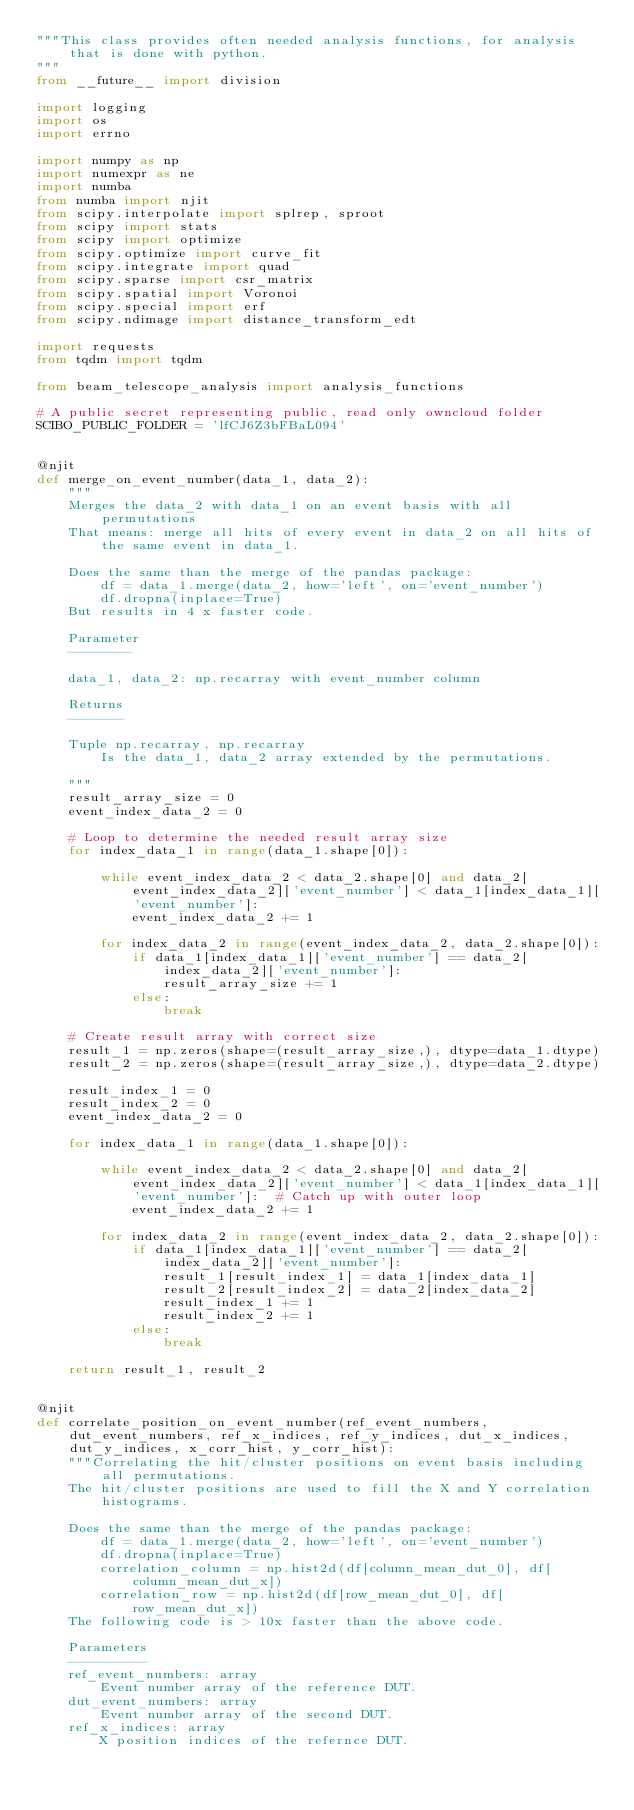<code> <loc_0><loc_0><loc_500><loc_500><_Python_>"""This class provides often needed analysis functions, for analysis that is done with python.
"""
from __future__ import division

import logging
import os
import errno

import numpy as np
import numexpr as ne
import numba
from numba import njit
from scipy.interpolate import splrep, sproot
from scipy import stats
from scipy import optimize
from scipy.optimize import curve_fit
from scipy.integrate import quad
from scipy.sparse import csr_matrix
from scipy.spatial import Voronoi
from scipy.special import erf
from scipy.ndimage import distance_transform_edt

import requests
from tqdm import tqdm

from beam_telescope_analysis import analysis_functions

# A public secret representing public, read only owncloud folder
SCIBO_PUBLIC_FOLDER = 'lfCJ6Z3bFBaL094'


@njit
def merge_on_event_number(data_1, data_2):
    """
    Merges the data_2 with data_1 on an event basis with all permutations
    That means: merge all hits of every event in data_2 on all hits of the same event in data_1.

    Does the same than the merge of the pandas package:
        df = data_1.merge(data_2, how='left', on='event_number')
        df.dropna(inplace=True)
    But results in 4 x faster code.

    Parameter
    --------

    data_1, data_2: np.recarray with event_number column

    Returns
    -------

    Tuple np.recarray, np.recarray
        Is the data_1, data_2 array extended by the permutations.

    """
    result_array_size = 0
    event_index_data_2 = 0

    # Loop to determine the needed result array size
    for index_data_1 in range(data_1.shape[0]):

        while event_index_data_2 < data_2.shape[0] and data_2[event_index_data_2]['event_number'] < data_1[index_data_1]['event_number']:
            event_index_data_2 += 1

        for index_data_2 in range(event_index_data_2, data_2.shape[0]):
            if data_1[index_data_1]['event_number'] == data_2[index_data_2]['event_number']:
                result_array_size += 1
            else:
                break

    # Create result array with correct size
    result_1 = np.zeros(shape=(result_array_size,), dtype=data_1.dtype)
    result_2 = np.zeros(shape=(result_array_size,), dtype=data_2.dtype)

    result_index_1 = 0
    result_index_2 = 0
    event_index_data_2 = 0

    for index_data_1 in range(data_1.shape[0]):

        while event_index_data_2 < data_2.shape[0] and data_2[event_index_data_2]['event_number'] < data_1[index_data_1]['event_number']:  # Catch up with outer loop
            event_index_data_2 += 1

        for index_data_2 in range(event_index_data_2, data_2.shape[0]):
            if data_1[index_data_1]['event_number'] == data_2[index_data_2]['event_number']:
                result_1[result_index_1] = data_1[index_data_1]
                result_2[result_index_2] = data_2[index_data_2]
                result_index_1 += 1
                result_index_2 += 1
            else:
                break

    return result_1, result_2


@njit
def correlate_position_on_event_number(ref_event_numbers, dut_event_numbers, ref_x_indices, ref_y_indices, dut_x_indices, dut_y_indices, x_corr_hist, y_corr_hist):
    """Correlating the hit/cluster positions on event basis including all permutations.
    The hit/cluster positions are used to fill the X and Y correlation histograms.

    Does the same than the merge of the pandas package:
        df = data_1.merge(data_2, how='left', on='event_number')
        df.dropna(inplace=True)
        correlation_column = np.hist2d(df[column_mean_dut_0], df[column_mean_dut_x])
        correlation_row = np.hist2d(df[row_mean_dut_0], df[row_mean_dut_x])
    The following code is > 10x faster than the above code.

    Parameters
    ----------
    ref_event_numbers: array
        Event number array of the reference DUT.
    dut_event_numbers: array
        Event number array of the second DUT.
    ref_x_indices: array
        X position indices of the refernce DUT.</code> 